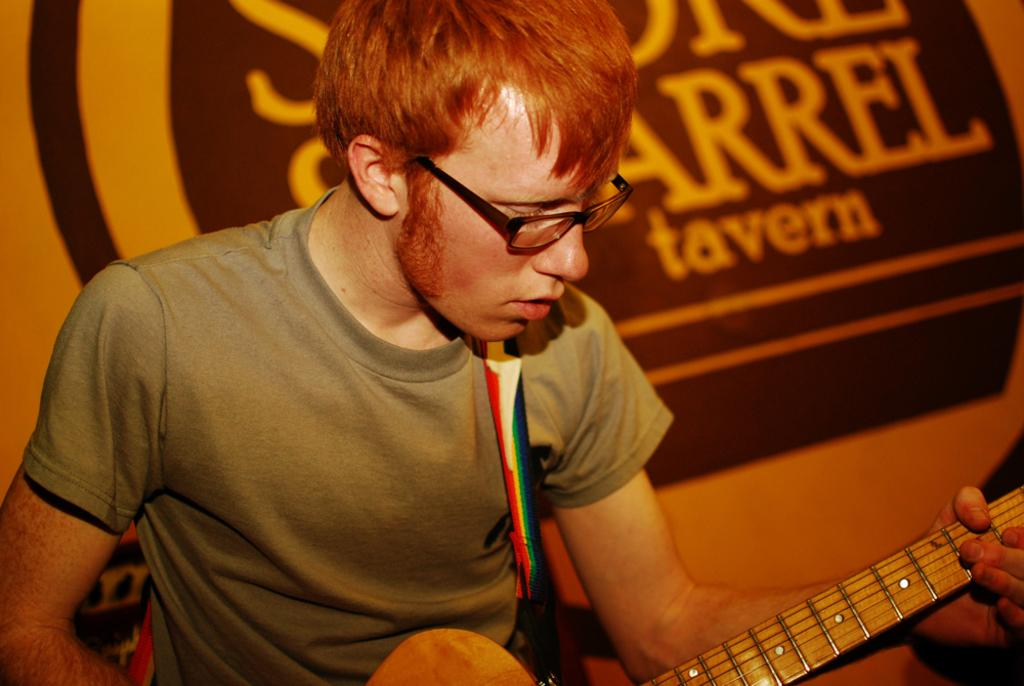What is the main subject of the image? There is a man in the image. What is the man holding in the image? The man is holding a guitar. What is the man doing with the guitar? The man is playing the guitar. What color is the sweater the man is wearing in the image? There is no mention of a sweater in the image, so we cannot determine its color. 